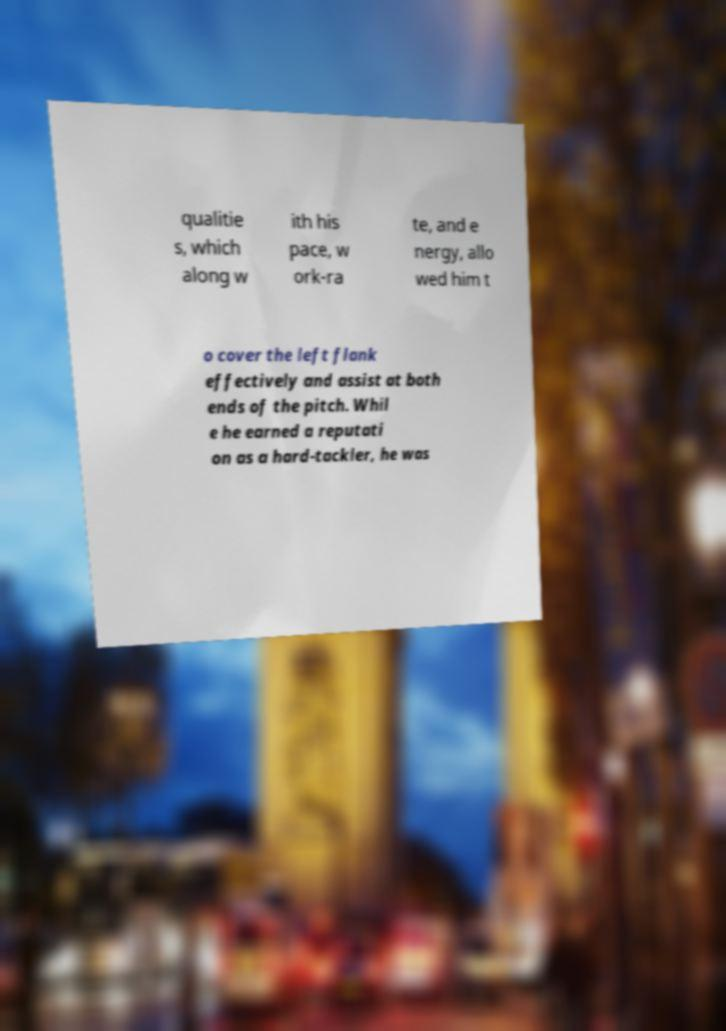Could you assist in decoding the text presented in this image and type it out clearly? qualitie s, which along w ith his pace, w ork-ra te, and e nergy, allo wed him t o cover the left flank effectively and assist at both ends of the pitch. Whil e he earned a reputati on as a hard-tackler, he was 